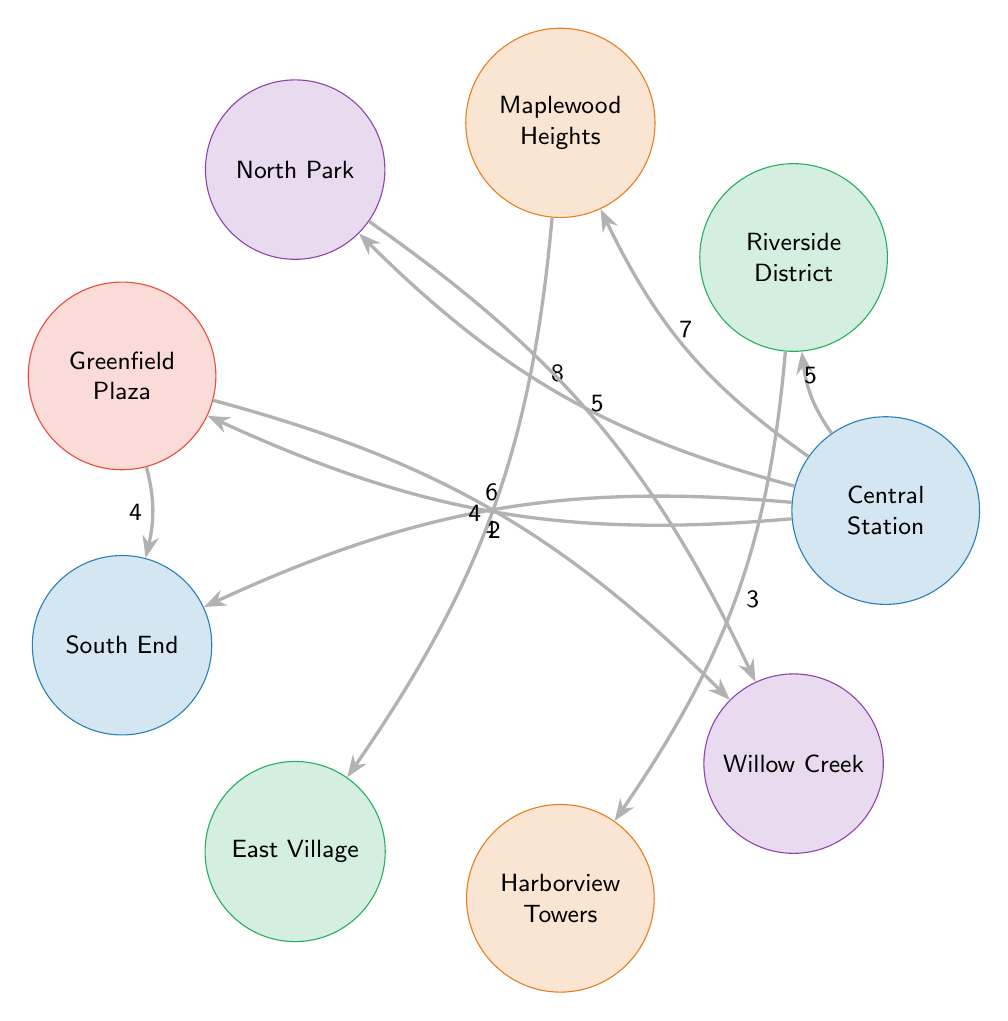What is the connection value between Central Station and Riverside District? In the diagram, the connection between Central Station and Riverside District is represented by an edge that has the value of 5. This value indicates the strength or frequency of the connection.
Answer: 5 Which residential area has the highest connection value from Central Station? By examining the edges connected to Central Station, Maplewood Heights has the highest connection value of 7, indicating it has the strongest connection to Central Station among the residential areas.
Answer: Maplewood Heights How many nodes are connected to Greenfield Plaza? Greenfield Plaza is connected to two other nodes: South End with a connection value of 4 and Willow Creek with a connection value of 2. Therefore, there are a total of two connections.
Answer: 2 What is the connection value between North Park and Willow Creek? The edge connecting North Park to Willow Creek indicates a connection value of 5, which is displayed on the diagram next to the corresponding connecting line.
Answer: 5 Which residential area is accessible from both Riverside District and Maplewood Heights? Both Riverside District and Maplewood Heights connect to Harborview Towers, making it the residential area that is accessible from both these locations according to the diagram.
Answer: Harborview Towers How do the connections from Central Station compare to those from Greenfield Plaza? Central Station has connections to five areas (Riverside District, Maplewood Heights, North Park, Greenfield Plaza, and South End) while Greenfield Plaza connects to two areas (South End and Willow Creek), showing that Central Station has more connections than Greenfield Plaza.
Answer: More connections Which area has the weakest connection from Central Station? The weakest connection from Central Station is to South End, which has a connection value of 4, indicating it has the lowest frequency in comparison to the other connecting areas.
Answer: South End What is the total number of connections originating from Central Station? Central Station has a total of five distinct connections to other areas: Riverside District, Maplewood Heights, North Park, Greenfield Plaza, and South End. Thus, the total count is five.
Answer: 5 Is there a direct connection from East Village to Central Station? No, the diagram does not illustrate any direct connection between East Village and Central Station, meaning there is no edge linking these specific locations.
Answer: No 